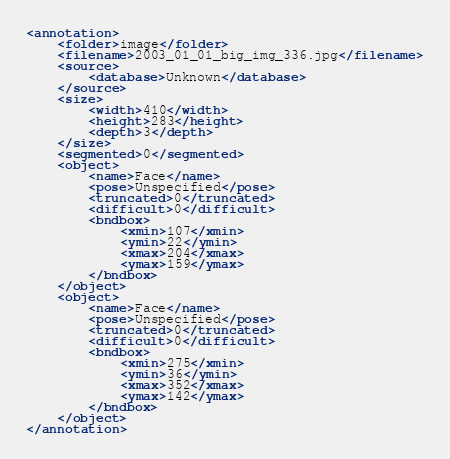<code> <loc_0><loc_0><loc_500><loc_500><_XML_><annotation>
    <folder>image</folder>
    <filename>2003_01_01_big_img_336.jpg</filename>
    <source>
        <database>Unknown</database>
    </source>
    <size>
        <width>410</width>
        <height>283</height>
        <depth>3</depth>
    </size>
    <segmented>0</segmented>
    <object>
        <name>Face</name>
        <pose>Unspecified</pose>
        <truncated>0</truncated>
        <difficult>0</difficult>
        <bndbox>
            <xmin>107</xmin>
            <ymin>22</ymin>
            <xmax>204</xmax>
            <ymax>159</ymax>
        </bndbox>
    </object>
    <object>
        <name>Face</name>
        <pose>Unspecified</pose>
        <truncated>0</truncated>
        <difficult>0</difficult>
        <bndbox>
            <xmin>275</xmin>
            <ymin>36</ymin>
            <xmax>352</xmax>
            <ymax>142</ymax>
        </bndbox>
    </object>
</annotation></code> 